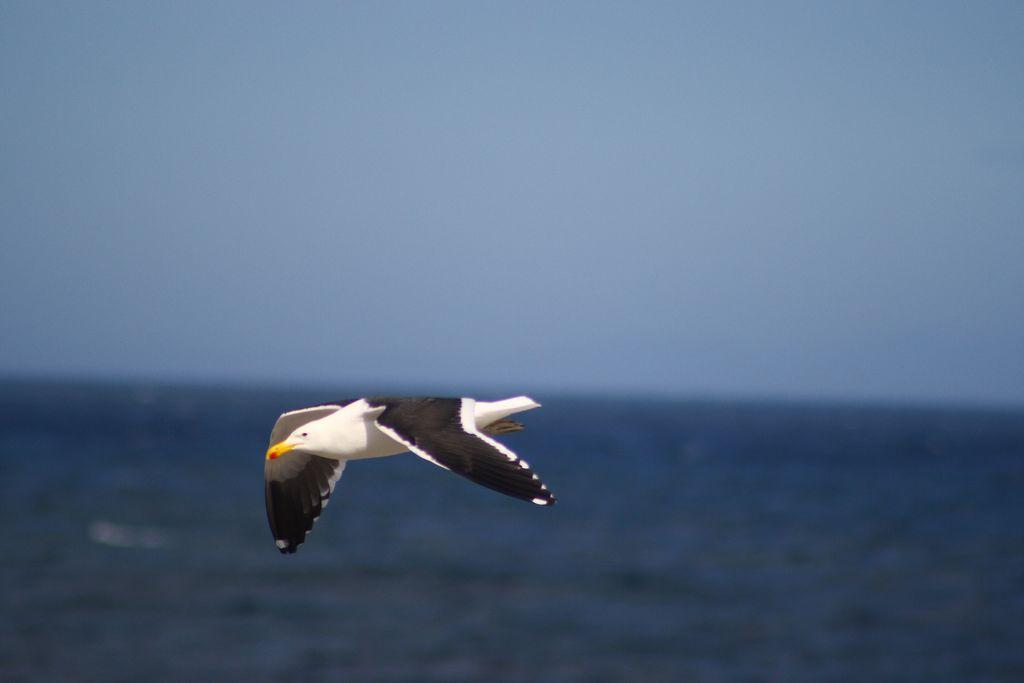What is the main subject of the image? There is a bird flying in the air. What can be observed about the background of the image? The background of the image is blurred. What natural element is visible in the image? There is water visible in the image. What part of the sky is visible in the image? The sky is visible in the background of the image. What type of horn can be heard in the image? There is no horn present in the image, and therefore no sound can be heard. What flavor of ice cream is being served at the place in the image? There is no place or ice cream mentioned in the image; it features a bird flying in the air. 